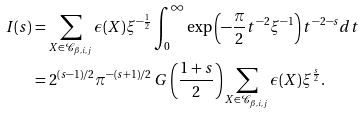Convert formula to latex. <formula><loc_0><loc_0><loc_500><loc_500>I ( s ) & = \sum _ { X \in \mathcal { C } _ { \beta , i , j } } \epsilon ( X ) \xi ^ { - \frac { 1 } { 2 } } \int _ { 0 } ^ { \infty } \exp \left ( - \frac { \pi } { 2 } t ^ { - 2 } \xi ^ { - 1 } \right ) t ^ { - 2 - s } d t \\ & = 2 ^ { ( s - 1 ) / 2 } \pi ^ { - ( s + 1 ) / 2 } \ G \left ( \frac { 1 + s } { 2 } \right ) \sum _ { X \in \mathcal { C } _ { \beta , i , j } } \epsilon ( X ) \xi ^ { \frac { s } 2 } .</formula> 